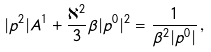Convert formula to latex. <formula><loc_0><loc_0><loc_500><loc_500>| p ^ { 2 } | A ^ { 1 } + \frac { \aleph ^ { 2 } } { 3 } \beta | p ^ { 0 } | ^ { 2 } = \frac { 1 } { \beta ^ { 2 } | p ^ { 0 } | } \, ,</formula> 